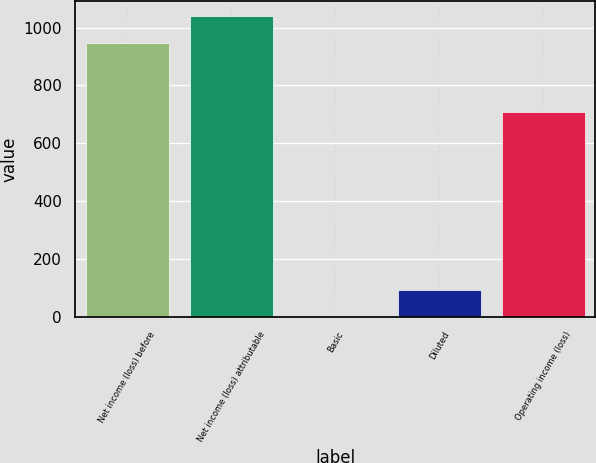Convert chart to OTSL. <chart><loc_0><loc_0><loc_500><loc_500><bar_chart><fcel>Net income (loss) before<fcel>Net income (loss) attributable<fcel>Basic<fcel>Diluted<fcel>Operating income (loss)<nl><fcel>945<fcel>1039.5<fcel>0.01<fcel>94.51<fcel>708<nl></chart> 